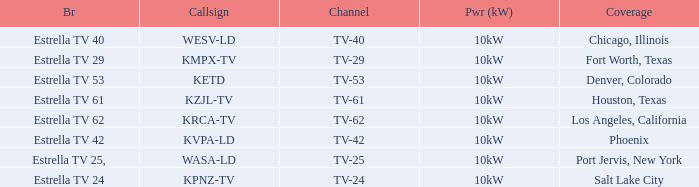Which city did kpnz-tv provide coverage for? Salt Lake City. 